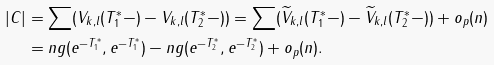<formula> <loc_0><loc_0><loc_500><loc_500>\left | C \right | & = \sum ( V _ { k , l } ( T _ { 1 } ^ { * } - ) - V _ { k , l } ( T _ { 2 } ^ { * } - ) ) = \sum ( \widetilde { V } _ { k , l } ( T _ { 1 } ^ { * } - ) - \widetilde { V } _ { k , l } ( T _ { 2 } ^ { * } - ) ) + o _ { p } ( n ) \\ & = n g ( e ^ { - T _ { 1 } ^ { * } } , e ^ { - T _ { 1 } ^ { * } } ) - n g ( e ^ { - T _ { 2 } ^ { * } } , e ^ { - T _ { 2 } ^ { * } } ) + o _ { p } ( n ) .</formula> 